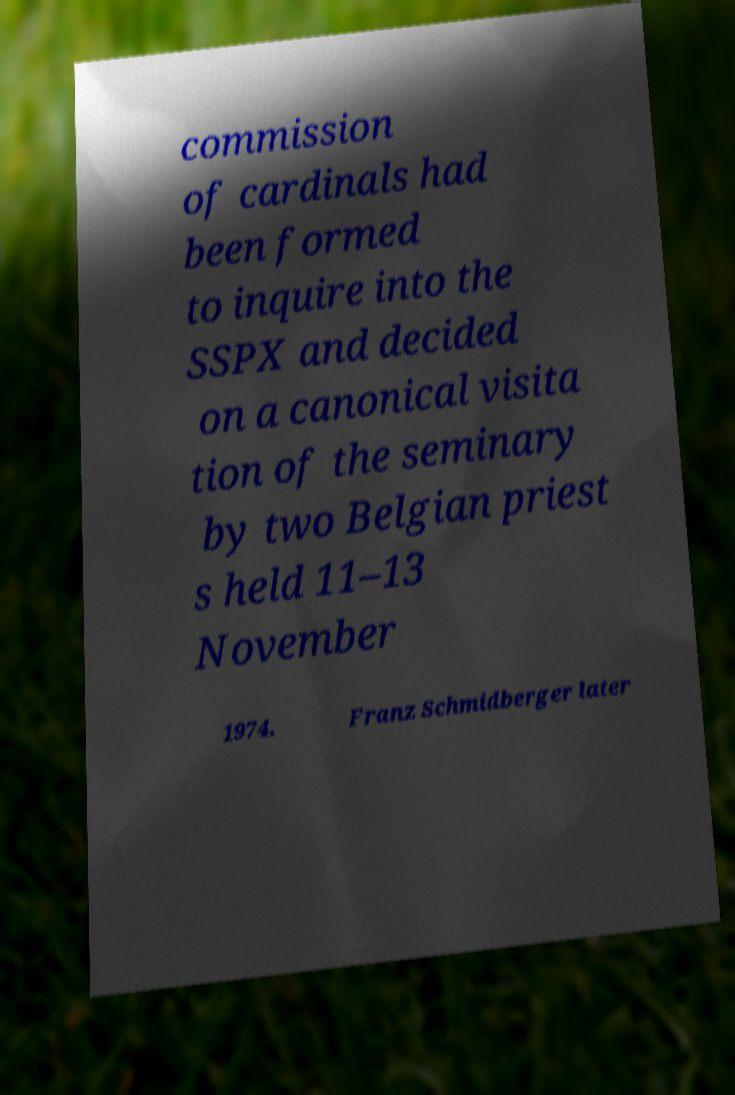Please read and relay the text visible in this image. What does it say? commission of cardinals had been formed to inquire into the SSPX and decided on a canonical visita tion of the seminary by two Belgian priest s held 11–13 November 1974. Franz Schmidberger later 